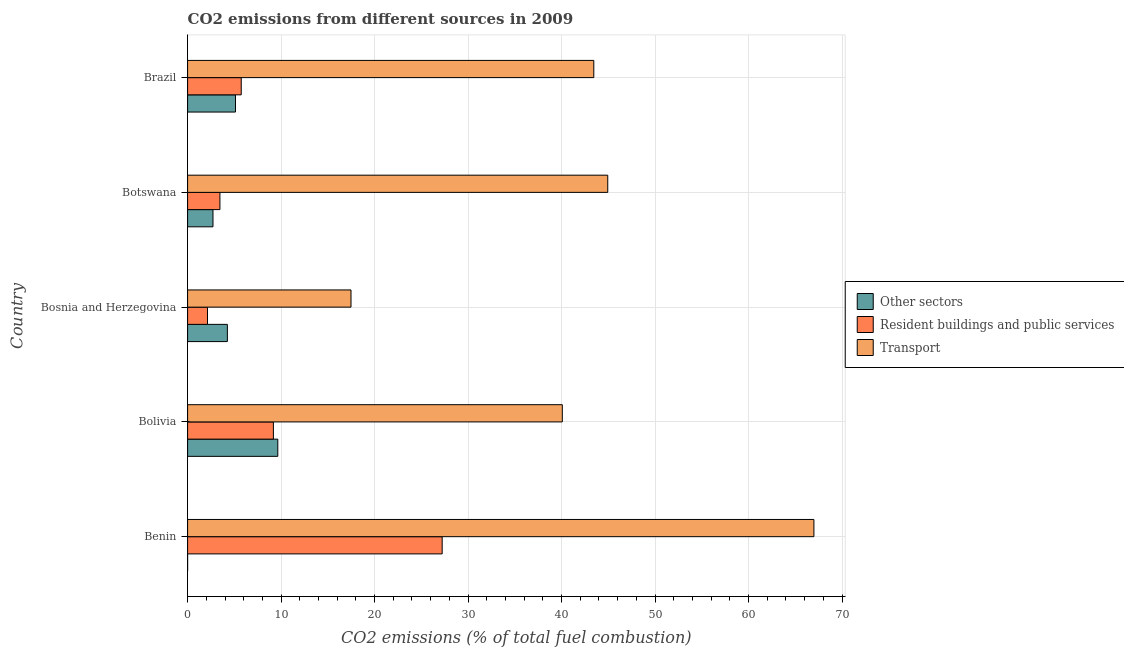How many different coloured bars are there?
Offer a terse response. 3. Are the number of bars on each tick of the Y-axis equal?
Ensure brevity in your answer.  No. How many bars are there on the 2nd tick from the top?
Offer a terse response. 3. How many bars are there on the 2nd tick from the bottom?
Your answer should be very brief. 3. What is the label of the 5th group of bars from the top?
Your answer should be very brief. Benin. In how many cases, is the number of bars for a given country not equal to the number of legend labels?
Your response must be concise. 1. Across all countries, what is the maximum percentage of co2 emissions from resident buildings and public services?
Ensure brevity in your answer.  27.23. Across all countries, what is the minimum percentage of co2 emissions from transport?
Make the answer very short. 17.48. In which country was the percentage of co2 emissions from transport maximum?
Provide a short and direct response. Benin. What is the total percentage of co2 emissions from other sectors in the graph?
Ensure brevity in your answer.  21.74. What is the difference between the percentage of co2 emissions from other sectors in Botswana and that in Brazil?
Your answer should be compact. -2.41. What is the difference between the percentage of co2 emissions from other sectors in Botswana and the percentage of co2 emissions from transport in Bolivia?
Provide a short and direct response. -37.36. What is the average percentage of co2 emissions from resident buildings and public services per country?
Your response must be concise. 9.54. What is the difference between the percentage of co2 emissions from other sectors and percentage of co2 emissions from transport in Botswana?
Your answer should be very brief. -42.22. In how many countries, is the percentage of co2 emissions from other sectors greater than 16 %?
Your answer should be very brief. 0. What is the ratio of the percentage of co2 emissions from transport in Botswana to that in Brazil?
Provide a succinct answer. 1.03. Is the difference between the percentage of co2 emissions from other sectors in Bolivia and Bosnia and Herzegovina greater than the difference between the percentage of co2 emissions from transport in Bolivia and Bosnia and Herzegovina?
Keep it short and to the point. No. What is the difference between the highest and the second highest percentage of co2 emissions from resident buildings and public services?
Offer a very short reply. 18.05. What is the difference between the highest and the lowest percentage of co2 emissions from other sectors?
Offer a very short reply. 9.65. In how many countries, is the percentage of co2 emissions from transport greater than the average percentage of co2 emissions from transport taken over all countries?
Ensure brevity in your answer.  3. How many bars are there?
Ensure brevity in your answer.  14. How many countries are there in the graph?
Provide a short and direct response. 5. What is the difference between two consecutive major ticks on the X-axis?
Offer a very short reply. 10. Does the graph contain grids?
Offer a very short reply. Yes. How are the legend labels stacked?
Make the answer very short. Vertical. What is the title of the graph?
Ensure brevity in your answer.  CO2 emissions from different sources in 2009. Does "Gaseous fuel" appear as one of the legend labels in the graph?
Your response must be concise. No. What is the label or title of the X-axis?
Your response must be concise. CO2 emissions (% of total fuel combustion). What is the label or title of the Y-axis?
Your answer should be very brief. Country. What is the CO2 emissions (% of total fuel combustion) of Other sectors in Benin?
Offer a very short reply. 0. What is the CO2 emissions (% of total fuel combustion) in Resident buildings and public services in Benin?
Offer a terse response. 27.23. What is the CO2 emissions (% of total fuel combustion) of Transport in Benin?
Provide a succinct answer. 66.99. What is the CO2 emissions (% of total fuel combustion) of Other sectors in Bolivia?
Offer a very short reply. 9.65. What is the CO2 emissions (% of total fuel combustion) of Resident buildings and public services in Bolivia?
Provide a short and direct response. 9.18. What is the CO2 emissions (% of total fuel combustion) of Transport in Bolivia?
Give a very brief answer. 40.08. What is the CO2 emissions (% of total fuel combustion) of Other sectors in Bosnia and Herzegovina?
Make the answer very short. 4.26. What is the CO2 emissions (% of total fuel combustion) of Resident buildings and public services in Bosnia and Herzegovina?
Your response must be concise. 2.13. What is the CO2 emissions (% of total fuel combustion) of Transport in Bosnia and Herzegovina?
Offer a very short reply. 17.48. What is the CO2 emissions (% of total fuel combustion) of Other sectors in Botswana?
Offer a terse response. 2.72. What is the CO2 emissions (% of total fuel combustion) in Resident buildings and public services in Botswana?
Keep it short and to the point. 3.46. What is the CO2 emissions (% of total fuel combustion) of Transport in Botswana?
Your answer should be very brief. 44.94. What is the CO2 emissions (% of total fuel combustion) in Other sectors in Brazil?
Make the answer very short. 5.12. What is the CO2 emissions (% of total fuel combustion) of Resident buildings and public services in Brazil?
Keep it short and to the point. 5.74. What is the CO2 emissions (% of total fuel combustion) of Transport in Brazil?
Offer a very short reply. 43.45. Across all countries, what is the maximum CO2 emissions (% of total fuel combustion) in Other sectors?
Provide a short and direct response. 9.65. Across all countries, what is the maximum CO2 emissions (% of total fuel combustion) of Resident buildings and public services?
Ensure brevity in your answer.  27.23. Across all countries, what is the maximum CO2 emissions (% of total fuel combustion) of Transport?
Offer a terse response. 66.99. Across all countries, what is the minimum CO2 emissions (% of total fuel combustion) in Other sectors?
Your response must be concise. 0. Across all countries, what is the minimum CO2 emissions (% of total fuel combustion) of Resident buildings and public services?
Offer a very short reply. 2.13. Across all countries, what is the minimum CO2 emissions (% of total fuel combustion) in Transport?
Your answer should be compact. 17.48. What is the total CO2 emissions (% of total fuel combustion) of Other sectors in the graph?
Offer a very short reply. 21.74. What is the total CO2 emissions (% of total fuel combustion) of Resident buildings and public services in the graph?
Give a very brief answer. 47.73. What is the total CO2 emissions (% of total fuel combustion) in Transport in the graph?
Offer a terse response. 212.93. What is the difference between the CO2 emissions (% of total fuel combustion) of Resident buildings and public services in Benin and that in Bolivia?
Provide a succinct answer. 18.05. What is the difference between the CO2 emissions (% of total fuel combustion) in Transport in Benin and that in Bolivia?
Ensure brevity in your answer.  26.91. What is the difference between the CO2 emissions (% of total fuel combustion) in Resident buildings and public services in Benin and that in Bosnia and Herzegovina?
Your answer should be compact. 25.1. What is the difference between the CO2 emissions (% of total fuel combustion) in Transport in Benin and that in Bosnia and Herzegovina?
Your answer should be very brief. 49.51. What is the difference between the CO2 emissions (% of total fuel combustion) of Resident buildings and public services in Benin and that in Botswana?
Your answer should be compact. 23.77. What is the difference between the CO2 emissions (% of total fuel combustion) of Transport in Benin and that in Botswana?
Ensure brevity in your answer.  22.05. What is the difference between the CO2 emissions (% of total fuel combustion) in Resident buildings and public services in Benin and that in Brazil?
Give a very brief answer. 21.49. What is the difference between the CO2 emissions (% of total fuel combustion) in Transport in Benin and that in Brazil?
Provide a succinct answer. 23.54. What is the difference between the CO2 emissions (% of total fuel combustion) in Other sectors in Bolivia and that in Bosnia and Herzegovina?
Ensure brevity in your answer.  5.39. What is the difference between the CO2 emissions (% of total fuel combustion) of Resident buildings and public services in Bolivia and that in Bosnia and Herzegovina?
Your answer should be compact. 7.05. What is the difference between the CO2 emissions (% of total fuel combustion) in Transport in Bolivia and that in Bosnia and Herzegovina?
Give a very brief answer. 22.6. What is the difference between the CO2 emissions (% of total fuel combustion) of Other sectors in Bolivia and that in Botswana?
Ensure brevity in your answer.  6.93. What is the difference between the CO2 emissions (% of total fuel combustion) in Resident buildings and public services in Bolivia and that in Botswana?
Your answer should be compact. 5.72. What is the difference between the CO2 emissions (% of total fuel combustion) in Transport in Bolivia and that in Botswana?
Ensure brevity in your answer.  -4.86. What is the difference between the CO2 emissions (% of total fuel combustion) of Other sectors in Bolivia and that in Brazil?
Your answer should be compact. 4.52. What is the difference between the CO2 emissions (% of total fuel combustion) in Resident buildings and public services in Bolivia and that in Brazil?
Provide a short and direct response. 3.44. What is the difference between the CO2 emissions (% of total fuel combustion) in Transport in Bolivia and that in Brazil?
Your answer should be compact. -3.37. What is the difference between the CO2 emissions (% of total fuel combustion) of Other sectors in Bosnia and Herzegovina and that in Botswana?
Ensure brevity in your answer.  1.54. What is the difference between the CO2 emissions (% of total fuel combustion) of Resident buildings and public services in Bosnia and Herzegovina and that in Botswana?
Your response must be concise. -1.33. What is the difference between the CO2 emissions (% of total fuel combustion) in Transport in Bosnia and Herzegovina and that in Botswana?
Ensure brevity in your answer.  -27.46. What is the difference between the CO2 emissions (% of total fuel combustion) of Other sectors in Bosnia and Herzegovina and that in Brazil?
Offer a very short reply. -0.87. What is the difference between the CO2 emissions (% of total fuel combustion) of Resident buildings and public services in Bosnia and Herzegovina and that in Brazil?
Keep it short and to the point. -3.61. What is the difference between the CO2 emissions (% of total fuel combustion) in Transport in Bosnia and Herzegovina and that in Brazil?
Your answer should be very brief. -25.97. What is the difference between the CO2 emissions (% of total fuel combustion) in Other sectors in Botswana and that in Brazil?
Provide a succinct answer. -2.41. What is the difference between the CO2 emissions (% of total fuel combustion) of Resident buildings and public services in Botswana and that in Brazil?
Keep it short and to the point. -2.28. What is the difference between the CO2 emissions (% of total fuel combustion) in Transport in Botswana and that in Brazil?
Provide a short and direct response. 1.49. What is the difference between the CO2 emissions (% of total fuel combustion) of Resident buildings and public services in Benin and the CO2 emissions (% of total fuel combustion) of Transport in Bolivia?
Keep it short and to the point. -12.85. What is the difference between the CO2 emissions (% of total fuel combustion) of Resident buildings and public services in Benin and the CO2 emissions (% of total fuel combustion) of Transport in Bosnia and Herzegovina?
Ensure brevity in your answer.  9.75. What is the difference between the CO2 emissions (% of total fuel combustion) of Resident buildings and public services in Benin and the CO2 emissions (% of total fuel combustion) of Transport in Botswana?
Offer a terse response. -17.71. What is the difference between the CO2 emissions (% of total fuel combustion) of Resident buildings and public services in Benin and the CO2 emissions (% of total fuel combustion) of Transport in Brazil?
Offer a terse response. -16.22. What is the difference between the CO2 emissions (% of total fuel combustion) in Other sectors in Bolivia and the CO2 emissions (% of total fuel combustion) in Resident buildings and public services in Bosnia and Herzegovina?
Your answer should be very brief. 7.52. What is the difference between the CO2 emissions (% of total fuel combustion) in Other sectors in Bolivia and the CO2 emissions (% of total fuel combustion) in Transport in Bosnia and Herzegovina?
Offer a very short reply. -7.83. What is the difference between the CO2 emissions (% of total fuel combustion) of Resident buildings and public services in Bolivia and the CO2 emissions (% of total fuel combustion) of Transport in Bosnia and Herzegovina?
Provide a short and direct response. -8.3. What is the difference between the CO2 emissions (% of total fuel combustion) in Other sectors in Bolivia and the CO2 emissions (% of total fuel combustion) in Resident buildings and public services in Botswana?
Ensure brevity in your answer.  6.19. What is the difference between the CO2 emissions (% of total fuel combustion) of Other sectors in Bolivia and the CO2 emissions (% of total fuel combustion) of Transport in Botswana?
Keep it short and to the point. -35.29. What is the difference between the CO2 emissions (% of total fuel combustion) in Resident buildings and public services in Bolivia and the CO2 emissions (% of total fuel combustion) in Transport in Botswana?
Offer a terse response. -35.76. What is the difference between the CO2 emissions (% of total fuel combustion) of Other sectors in Bolivia and the CO2 emissions (% of total fuel combustion) of Resident buildings and public services in Brazil?
Your answer should be compact. 3.91. What is the difference between the CO2 emissions (% of total fuel combustion) in Other sectors in Bolivia and the CO2 emissions (% of total fuel combustion) in Transport in Brazil?
Your response must be concise. -33.8. What is the difference between the CO2 emissions (% of total fuel combustion) in Resident buildings and public services in Bolivia and the CO2 emissions (% of total fuel combustion) in Transport in Brazil?
Your answer should be very brief. -34.27. What is the difference between the CO2 emissions (% of total fuel combustion) of Other sectors in Bosnia and Herzegovina and the CO2 emissions (% of total fuel combustion) of Resident buildings and public services in Botswana?
Ensure brevity in your answer.  0.8. What is the difference between the CO2 emissions (% of total fuel combustion) in Other sectors in Bosnia and Herzegovina and the CO2 emissions (% of total fuel combustion) in Transport in Botswana?
Offer a terse response. -40.68. What is the difference between the CO2 emissions (% of total fuel combustion) in Resident buildings and public services in Bosnia and Herzegovina and the CO2 emissions (% of total fuel combustion) in Transport in Botswana?
Keep it short and to the point. -42.81. What is the difference between the CO2 emissions (% of total fuel combustion) in Other sectors in Bosnia and Herzegovina and the CO2 emissions (% of total fuel combustion) in Resident buildings and public services in Brazil?
Make the answer very short. -1.48. What is the difference between the CO2 emissions (% of total fuel combustion) in Other sectors in Bosnia and Herzegovina and the CO2 emissions (% of total fuel combustion) in Transport in Brazil?
Give a very brief answer. -39.19. What is the difference between the CO2 emissions (% of total fuel combustion) of Resident buildings and public services in Bosnia and Herzegovina and the CO2 emissions (% of total fuel combustion) of Transport in Brazil?
Make the answer very short. -41.32. What is the difference between the CO2 emissions (% of total fuel combustion) of Other sectors in Botswana and the CO2 emissions (% of total fuel combustion) of Resident buildings and public services in Brazil?
Ensure brevity in your answer.  -3.02. What is the difference between the CO2 emissions (% of total fuel combustion) of Other sectors in Botswana and the CO2 emissions (% of total fuel combustion) of Transport in Brazil?
Offer a very short reply. -40.73. What is the difference between the CO2 emissions (% of total fuel combustion) of Resident buildings and public services in Botswana and the CO2 emissions (% of total fuel combustion) of Transport in Brazil?
Offer a terse response. -39.99. What is the average CO2 emissions (% of total fuel combustion) in Other sectors per country?
Ensure brevity in your answer.  4.35. What is the average CO2 emissions (% of total fuel combustion) of Resident buildings and public services per country?
Ensure brevity in your answer.  9.55. What is the average CO2 emissions (% of total fuel combustion) in Transport per country?
Provide a short and direct response. 42.59. What is the difference between the CO2 emissions (% of total fuel combustion) in Resident buildings and public services and CO2 emissions (% of total fuel combustion) in Transport in Benin?
Your response must be concise. -39.76. What is the difference between the CO2 emissions (% of total fuel combustion) in Other sectors and CO2 emissions (% of total fuel combustion) in Resident buildings and public services in Bolivia?
Your answer should be very brief. 0.47. What is the difference between the CO2 emissions (% of total fuel combustion) in Other sectors and CO2 emissions (% of total fuel combustion) in Transport in Bolivia?
Provide a short and direct response. -30.43. What is the difference between the CO2 emissions (% of total fuel combustion) in Resident buildings and public services and CO2 emissions (% of total fuel combustion) in Transport in Bolivia?
Keep it short and to the point. -30.9. What is the difference between the CO2 emissions (% of total fuel combustion) of Other sectors and CO2 emissions (% of total fuel combustion) of Resident buildings and public services in Bosnia and Herzegovina?
Give a very brief answer. 2.13. What is the difference between the CO2 emissions (% of total fuel combustion) of Other sectors and CO2 emissions (% of total fuel combustion) of Transport in Bosnia and Herzegovina?
Offer a terse response. -13.22. What is the difference between the CO2 emissions (% of total fuel combustion) in Resident buildings and public services and CO2 emissions (% of total fuel combustion) in Transport in Bosnia and Herzegovina?
Offer a terse response. -15.35. What is the difference between the CO2 emissions (% of total fuel combustion) of Other sectors and CO2 emissions (% of total fuel combustion) of Resident buildings and public services in Botswana?
Provide a succinct answer. -0.74. What is the difference between the CO2 emissions (% of total fuel combustion) of Other sectors and CO2 emissions (% of total fuel combustion) of Transport in Botswana?
Provide a short and direct response. -42.22. What is the difference between the CO2 emissions (% of total fuel combustion) of Resident buildings and public services and CO2 emissions (% of total fuel combustion) of Transport in Botswana?
Ensure brevity in your answer.  -41.48. What is the difference between the CO2 emissions (% of total fuel combustion) in Other sectors and CO2 emissions (% of total fuel combustion) in Resident buildings and public services in Brazil?
Provide a succinct answer. -0.61. What is the difference between the CO2 emissions (% of total fuel combustion) in Other sectors and CO2 emissions (% of total fuel combustion) in Transport in Brazil?
Make the answer very short. -38.32. What is the difference between the CO2 emissions (% of total fuel combustion) in Resident buildings and public services and CO2 emissions (% of total fuel combustion) in Transport in Brazil?
Ensure brevity in your answer.  -37.71. What is the ratio of the CO2 emissions (% of total fuel combustion) of Resident buildings and public services in Benin to that in Bolivia?
Provide a succinct answer. 2.97. What is the ratio of the CO2 emissions (% of total fuel combustion) in Transport in Benin to that in Bolivia?
Offer a terse response. 1.67. What is the ratio of the CO2 emissions (% of total fuel combustion) of Resident buildings and public services in Benin to that in Bosnia and Herzegovina?
Your response must be concise. 12.8. What is the ratio of the CO2 emissions (% of total fuel combustion) in Transport in Benin to that in Bosnia and Herzegovina?
Your answer should be compact. 3.83. What is the ratio of the CO2 emissions (% of total fuel combustion) of Resident buildings and public services in Benin to that in Botswana?
Provide a short and direct response. 7.88. What is the ratio of the CO2 emissions (% of total fuel combustion) of Transport in Benin to that in Botswana?
Your answer should be compact. 1.49. What is the ratio of the CO2 emissions (% of total fuel combustion) in Resident buildings and public services in Benin to that in Brazil?
Provide a short and direct response. 4.75. What is the ratio of the CO2 emissions (% of total fuel combustion) of Transport in Benin to that in Brazil?
Your response must be concise. 1.54. What is the ratio of the CO2 emissions (% of total fuel combustion) in Other sectors in Bolivia to that in Bosnia and Herzegovina?
Ensure brevity in your answer.  2.27. What is the ratio of the CO2 emissions (% of total fuel combustion) in Resident buildings and public services in Bolivia to that in Bosnia and Herzegovina?
Offer a very short reply. 4.31. What is the ratio of the CO2 emissions (% of total fuel combustion) of Transport in Bolivia to that in Bosnia and Herzegovina?
Make the answer very short. 2.29. What is the ratio of the CO2 emissions (% of total fuel combustion) in Other sectors in Bolivia to that in Botswana?
Offer a very short reply. 3.55. What is the ratio of the CO2 emissions (% of total fuel combustion) of Resident buildings and public services in Bolivia to that in Botswana?
Ensure brevity in your answer.  2.65. What is the ratio of the CO2 emissions (% of total fuel combustion) in Transport in Bolivia to that in Botswana?
Your answer should be very brief. 0.89. What is the ratio of the CO2 emissions (% of total fuel combustion) of Other sectors in Bolivia to that in Brazil?
Provide a short and direct response. 1.88. What is the ratio of the CO2 emissions (% of total fuel combustion) of Resident buildings and public services in Bolivia to that in Brazil?
Ensure brevity in your answer.  1.6. What is the ratio of the CO2 emissions (% of total fuel combustion) in Transport in Bolivia to that in Brazil?
Keep it short and to the point. 0.92. What is the ratio of the CO2 emissions (% of total fuel combustion) in Other sectors in Bosnia and Herzegovina to that in Botswana?
Provide a short and direct response. 1.57. What is the ratio of the CO2 emissions (% of total fuel combustion) in Resident buildings and public services in Bosnia and Herzegovina to that in Botswana?
Make the answer very short. 0.62. What is the ratio of the CO2 emissions (% of total fuel combustion) of Transport in Bosnia and Herzegovina to that in Botswana?
Give a very brief answer. 0.39. What is the ratio of the CO2 emissions (% of total fuel combustion) in Other sectors in Bosnia and Herzegovina to that in Brazil?
Your answer should be compact. 0.83. What is the ratio of the CO2 emissions (% of total fuel combustion) of Resident buildings and public services in Bosnia and Herzegovina to that in Brazil?
Offer a very short reply. 0.37. What is the ratio of the CO2 emissions (% of total fuel combustion) in Transport in Bosnia and Herzegovina to that in Brazil?
Your response must be concise. 0.4. What is the ratio of the CO2 emissions (% of total fuel combustion) of Other sectors in Botswana to that in Brazil?
Give a very brief answer. 0.53. What is the ratio of the CO2 emissions (% of total fuel combustion) of Resident buildings and public services in Botswana to that in Brazil?
Provide a succinct answer. 0.6. What is the ratio of the CO2 emissions (% of total fuel combustion) in Transport in Botswana to that in Brazil?
Make the answer very short. 1.03. What is the difference between the highest and the second highest CO2 emissions (% of total fuel combustion) of Other sectors?
Your answer should be very brief. 4.52. What is the difference between the highest and the second highest CO2 emissions (% of total fuel combustion) of Resident buildings and public services?
Your answer should be very brief. 18.05. What is the difference between the highest and the second highest CO2 emissions (% of total fuel combustion) of Transport?
Your answer should be very brief. 22.05. What is the difference between the highest and the lowest CO2 emissions (% of total fuel combustion) of Other sectors?
Make the answer very short. 9.65. What is the difference between the highest and the lowest CO2 emissions (% of total fuel combustion) of Resident buildings and public services?
Your answer should be very brief. 25.1. What is the difference between the highest and the lowest CO2 emissions (% of total fuel combustion) in Transport?
Your response must be concise. 49.51. 